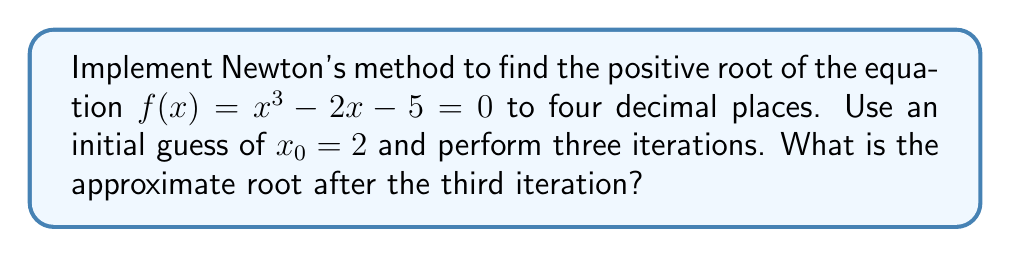Can you answer this question? Newton's method is an iterative technique for finding roots of a nonlinear equation. The formula for Newton's method is:

$$x_{n+1} = x_n - \frac{f(x_n)}{f'(x_n)}$$

Where $f(x_n)$ is the function evaluated at $x_n$, and $f'(x_n)$ is the derivative of the function evaluated at $x_n$.

For our problem:
$f(x) = x^3 - 2x - 5$
$f'(x) = 3x^2 - 2$

Step 1: Initial guess $x_0 = 2$

Step 2: First iteration
$$x_1 = 2 - \frac{2^3 - 2(2) - 5}{3(2)^2 - 2} = 2 - \frac{-1}{10} = 2.1000$$

Step 3: Second iteration
$$x_2 = 2.1000 - \frac{(2.1000)^3 - 2(2.1000) - 5}{3(2.1000)^2 - 2} = 2.1000 - \frac{0.2461}{11.2300} = 2.0781$$

Step 4: Third iteration
$$x_3 = 2.0781 - \frac{(2.0781)^3 - 2(2.0781) - 5}{3(2.0781)^2 - 2} = 2.0781 - \frac{0.0168}{11.0272} = 2.0766$$

Therefore, after three iterations, the approximate root to four decimal places is 2.0766.
Answer: 2.0766 